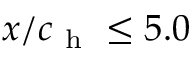<formula> <loc_0><loc_0><loc_500><loc_500>x / c _ { h } \leq 5 . 0 \</formula> 